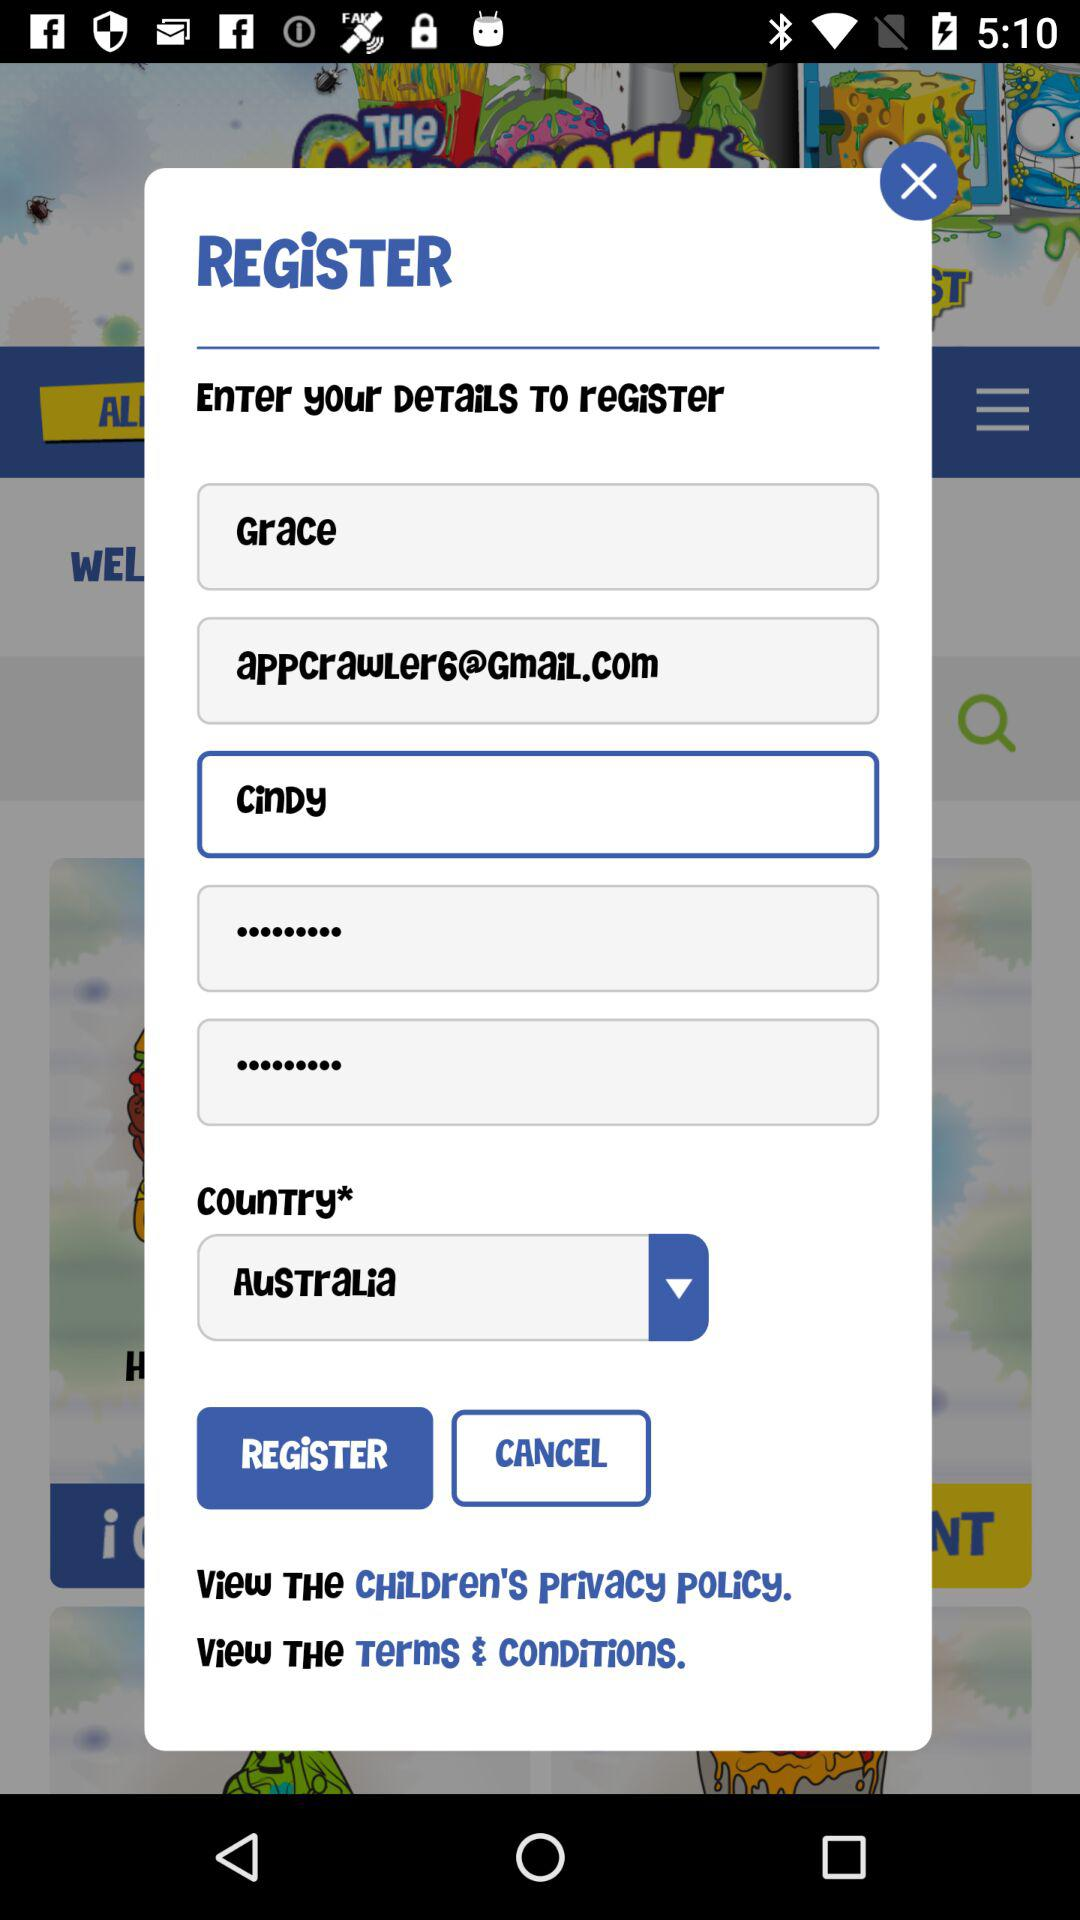What is the user name? The user name is Grace Cindy. 